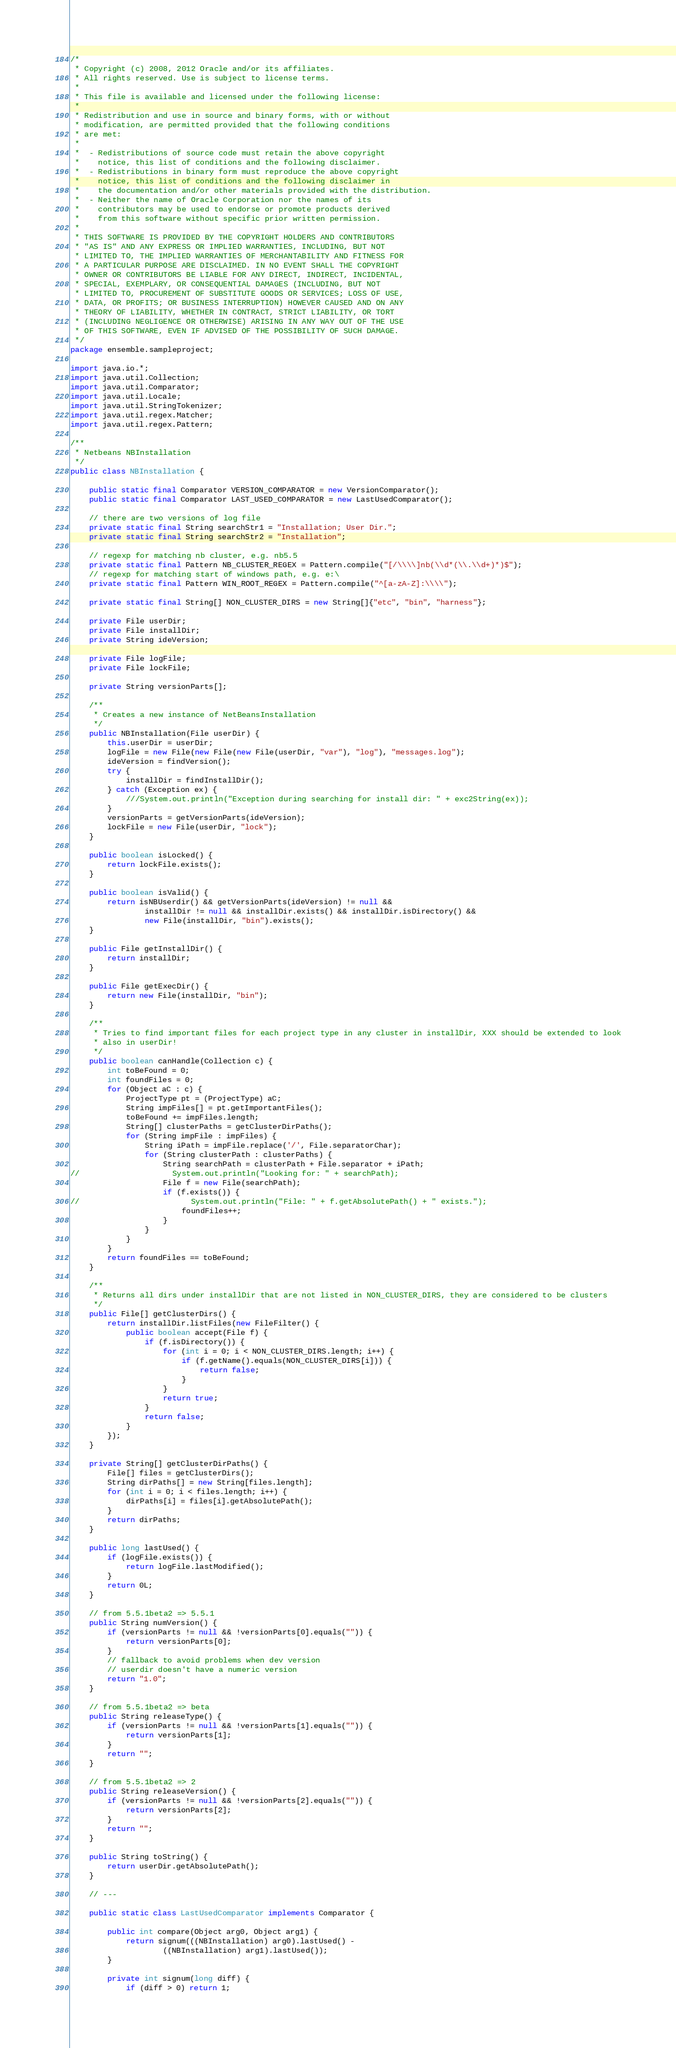<code> <loc_0><loc_0><loc_500><loc_500><_Java_>/*
 * Copyright (c) 2008, 2012 Oracle and/or its affiliates.
 * All rights reserved. Use is subject to license terms.
 *
 * This file is available and licensed under the following license:
 *
 * Redistribution and use in source and binary forms, with or without
 * modification, are permitted provided that the following conditions
 * are met:
 *
 *  - Redistributions of source code must retain the above copyright
 *    notice, this list of conditions and the following disclaimer.
 *  - Redistributions in binary form must reproduce the above copyright
 *    notice, this list of conditions and the following disclaimer in
 *    the documentation and/or other materials provided with the distribution.
 *  - Neither the name of Oracle Corporation nor the names of its
 *    contributors may be used to endorse or promote products derived
 *    from this software without specific prior written permission.
 *
 * THIS SOFTWARE IS PROVIDED BY THE COPYRIGHT HOLDERS AND CONTRIBUTORS
 * "AS IS" AND ANY EXPRESS OR IMPLIED WARRANTIES, INCLUDING, BUT NOT
 * LIMITED TO, THE IMPLIED WARRANTIES OF MERCHANTABILITY AND FITNESS FOR
 * A PARTICULAR PURPOSE ARE DISCLAIMED. IN NO EVENT SHALL THE COPYRIGHT
 * OWNER OR CONTRIBUTORS BE LIABLE FOR ANY DIRECT, INDIRECT, INCIDENTAL,
 * SPECIAL, EXEMPLARY, OR CONSEQUENTIAL DAMAGES (INCLUDING, BUT NOT
 * LIMITED TO, PROCUREMENT OF SUBSTITUTE GOODS OR SERVICES; LOSS OF USE,
 * DATA, OR PROFITS; OR BUSINESS INTERRUPTION) HOWEVER CAUSED AND ON ANY
 * THEORY OF LIABILITY, WHETHER IN CONTRACT, STRICT LIABILITY, OR TORT
 * (INCLUDING NEGLIGENCE OR OTHERWISE) ARISING IN ANY WAY OUT OF THE USE
 * OF THIS SOFTWARE, EVEN IF ADVISED OF THE POSSIBILITY OF SUCH DAMAGE.
 */
package ensemble.sampleproject;

import java.io.*;
import java.util.Collection;
import java.util.Comparator;
import java.util.Locale;
import java.util.StringTokenizer;
import java.util.regex.Matcher;
import java.util.regex.Pattern;

/**
 * Netbeans NBInstallation
 */
public class NBInstallation {

    public static final Comparator VERSION_COMPARATOR = new VersionComparator();
    public static final Comparator LAST_USED_COMPARATOR = new LastUsedComparator();

    // there are two versions of log file
    private static final String searchStr1 = "Installation; User Dir.";
    private static final String searchStr2 = "Installation";

    // regexp for matching nb cluster, e.g. nb5.5
    private static final Pattern NB_CLUSTER_REGEX = Pattern.compile("[/\\\\]nb(\\d*(\\.\\d+)*)$");
    // regexp for matching start of windows path, e.g. e:\
    private static final Pattern WIN_ROOT_REGEX = Pattern.compile("^[a-zA-Z]:\\\\");

    private static final String[] NON_CLUSTER_DIRS = new String[]{"etc", "bin", "harness"};

    private File userDir;
    private File installDir;
    private String ideVersion;

    private File logFile;
    private File lockFile;

    private String versionParts[];

    /**
     * Creates a new instance of NetBeansInstallation
     */
    public NBInstallation(File userDir) {
        this.userDir = userDir;
        logFile = new File(new File(new File(userDir, "var"), "log"), "messages.log");
        ideVersion = findVersion();
        try {
            installDir = findInstallDir();
        } catch (Exception ex) {
            ///System.out.println("Exception during searching for install dir: " + exc2String(ex));
        }
        versionParts = getVersionParts(ideVersion);
        lockFile = new File(userDir, "lock");
    }

    public boolean isLocked() {
        return lockFile.exists();
    }

    public boolean isValid() {
        return isNBUserdir() && getVersionParts(ideVersion) != null &&
                installDir != null && installDir.exists() && installDir.isDirectory() &&
                new File(installDir, "bin").exists();
    }

    public File getInstallDir() {
        return installDir;
    }

    public File getExecDir() {
        return new File(installDir, "bin");
    }

    /**
     * Tries to find important files for each project type in any cluster in installDir, XXX should be extended to look
     * also in userDir!
     */
    public boolean canHandle(Collection c) {
        int toBeFound = 0;
        int foundFiles = 0;
        for (Object aC : c) {
            ProjectType pt = (ProjectType) aC;
            String impFiles[] = pt.getImportantFiles();
            toBeFound += impFiles.length;
            String[] clusterPaths = getClusterDirPaths();
            for (String impFile : impFiles) {
                String iPath = impFile.replace('/', File.separatorChar);
                for (String clusterPath : clusterPaths) {
                    String searchPath = clusterPath + File.separator + iPath;
//                    System.out.println("Looking for: " + searchPath);
                    File f = new File(searchPath);
                    if (f.exists()) {
//                        System.out.println("File: " + f.getAbsolutePath() + " exists.");
                        foundFiles++;
                    }
                }
            }
        }
        return foundFiles == toBeFound;
    }

    /**
     * Returns all dirs under installDir that are not listed in NON_CLUSTER_DIRS, they are considered to be clusters
     */
    public File[] getClusterDirs() {
        return installDir.listFiles(new FileFilter() {
            public boolean accept(File f) {
                if (f.isDirectory()) {
                    for (int i = 0; i < NON_CLUSTER_DIRS.length; i++) {
                        if (f.getName().equals(NON_CLUSTER_DIRS[i])) {
                            return false;
                        }
                    }
                    return true;
                }
                return false;
            }
        });
    }

    private String[] getClusterDirPaths() {
        File[] files = getClusterDirs();
        String dirPaths[] = new String[files.length];
        for (int i = 0; i < files.length; i++) {
            dirPaths[i] = files[i].getAbsolutePath();
        }
        return dirPaths;
    }

    public long lastUsed() {
        if (logFile.exists()) {
            return logFile.lastModified();
        }
        return 0L;
    }

    // from 5.5.1beta2 => 5.5.1
    public String numVersion() {
        if (versionParts != null && !versionParts[0].equals("")) {
            return versionParts[0];
        }
        // fallback to avoid problems when dev version
        // userdir doesn't have a numeric version
        return "1.0";
    }

    // from 5.5.1beta2 => beta
    public String releaseType() {
        if (versionParts != null && !versionParts[1].equals("")) {
            return versionParts[1];
        }
        return "";
    }

    // from 5.5.1beta2 => 2
    public String releaseVersion() {
        if (versionParts != null && !versionParts[2].equals("")) {
            return versionParts[2];
        }
        return "";
    }

    public String toString() {
        return userDir.getAbsolutePath();
    }

    // ---

    public static class LastUsedComparator implements Comparator {

        public int compare(Object arg0, Object arg1) {
            return signum(((NBInstallation) arg0).lastUsed() -
                    ((NBInstallation) arg1).lastUsed());
        }

        private int signum(long diff) {
            if (diff > 0) return 1;</code> 